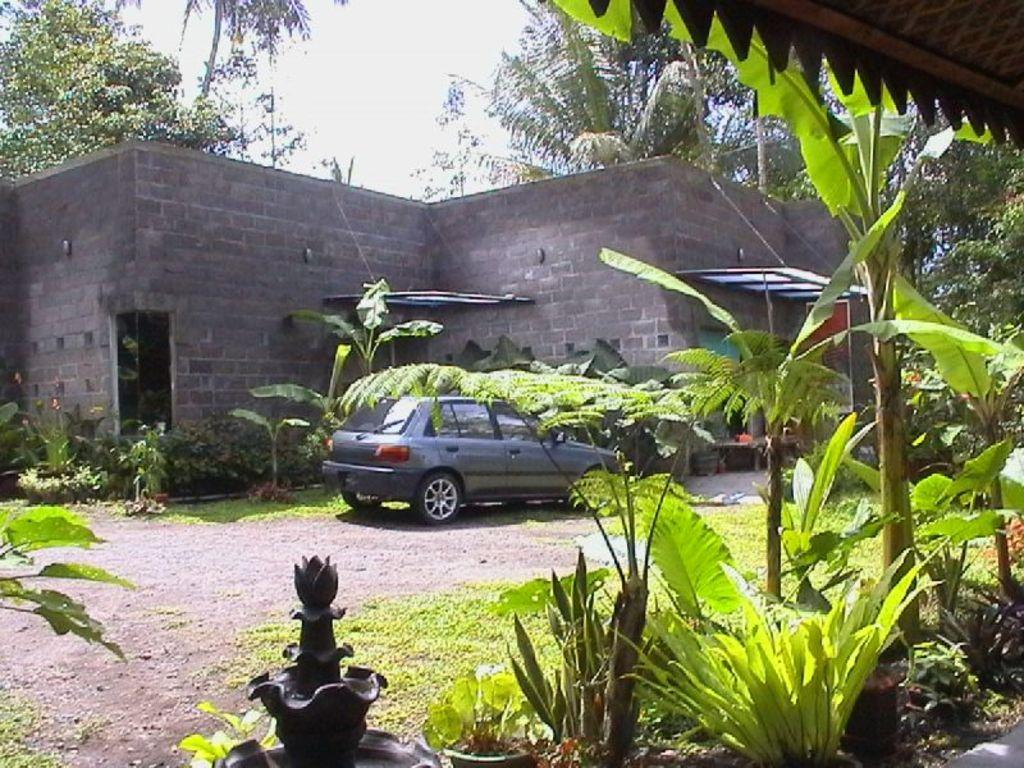What type of structure is visible in the image? There is a building in the image. What type of vegetation can be seen in the image? There are trees and plants in the image. What is parked in the image? A car is parked in the image. What is the condition of the sky in the image? The sky is cloudy in the image. What type of ground surface is visible in the image? There is grass on the ground in the image. What type of glue is being used to hold the houses together in the image? There are no houses present in the image, and therefore no glue or construction process can be observed. What type of liquid can be seen flowing from the trees in the image? There is no liquid flowing from the trees in the image; only the trees themselves are visible. 